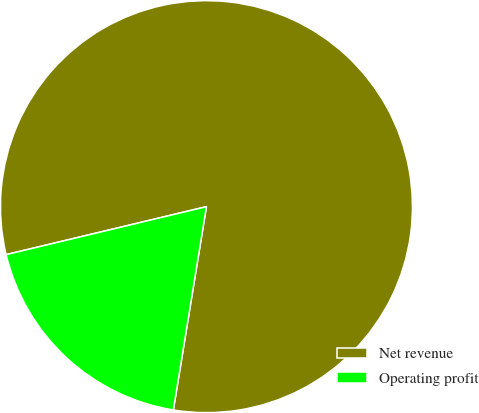Convert chart to OTSL. <chart><loc_0><loc_0><loc_500><loc_500><pie_chart><fcel>Net revenue<fcel>Operating profit<nl><fcel>81.31%<fcel>18.69%<nl></chart> 